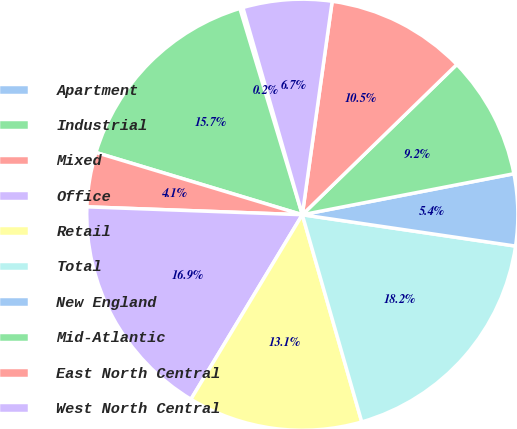<chart> <loc_0><loc_0><loc_500><loc_500><pie_chart><fcel>Apartment<fcel>Industrial<fcel>Mixed<fcel>Office<fcel>Retail<fcel>Total<fcel>New England<fcel>Mid-Atlantic<fcel>East North Central<fcel>West North Central<nl><fcel>0.23%<fcel>15.66%<fcel>4.08%<fcel>16.94%<fcel>13.09%<fcel>18.23%<fcel>5.37%<fcel>9.23%<fcel>10.51%<fcel>6.66%<nl></chart> 